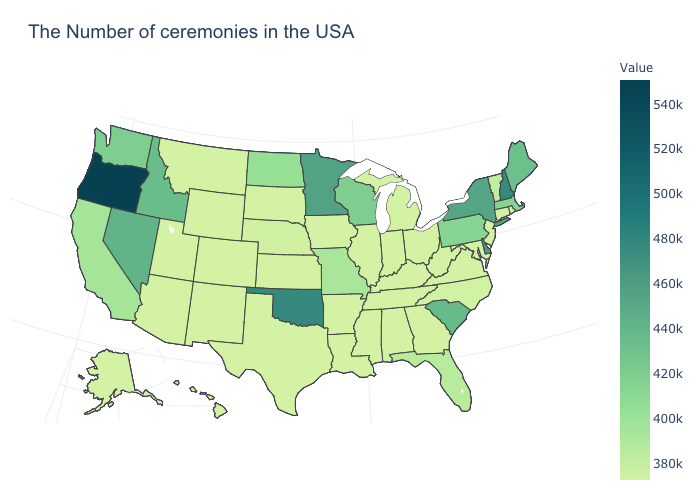Among the states that border Kansas , does Oklahoma have the lowest value?
Short answer required. No. Is the legend a continuous bar?
Quick response, please. Yes. Which states have the lowest value in the USA?
Be succinct. Rhode Island, Connecticut, New Jersey, Maryland, Virginia, West Virginia, Ohio, Georgia, Michigan, Kentucky, Indiana, Alabama, Tennessee, Illinois, Mississippi, Louisiana, Arkansas, Iowa, Kansas, Texas, South Dakota, Wyoming, Colorado, New Mexico, Utah, Montana, Arizona, Alaska, Hawaii. Which states have the lowest value in the USA?
Keep it brief. Rhode Island, Connecticut, New Jersey, Maryland, Virginia, West Virginia, Ohio, Georgia, Michigan, Kentucky, Indiana, Alabama, Tennessee, Illinois, Mississippi, Louisiana, Arkansas, Iowa, Kansas, Texas, South Dakota, Wyoming, Colorado, New Mexico, Utah, Montana, Arizona, Alaska, Hawaii. Is the legend a continuous bar?
Quick response, please. Yes. Which states have the highest value in the USA?
Short answer required. Oregon. Which states hav the highest value in the South?
Answer briefly. Oklahoma. 